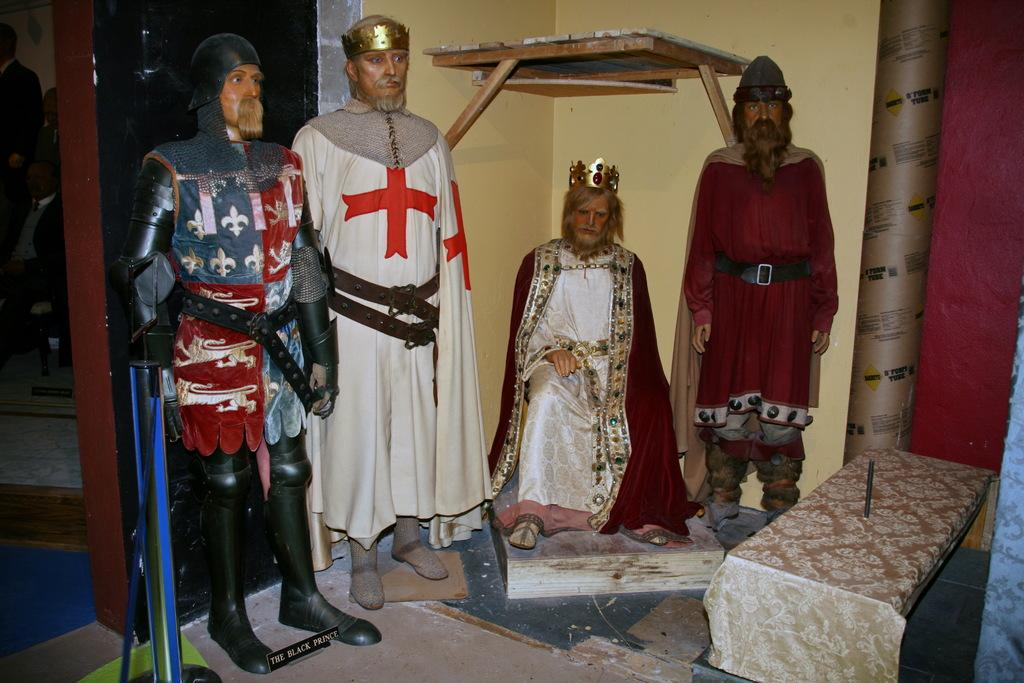How many mannequins are present in the image? There are four mannequins in the image. What is located at the bottom of the image? There is a floor at the bottom of the image. What can be seen in the background of the image? There is a wall in the background of the image. What is attached to the wall in the image? A rack is fixed to the wall. What is the location of the door in the image? There is a door to the left of the image. What type of government is depicted in the image? There is no depiction of a government in the image; it features four mannequins, a floor, a wall, a rack, and a door. Can you tell me the value of the pet in the image? There is no pet present in the image, so it is not possible to determine its value. 